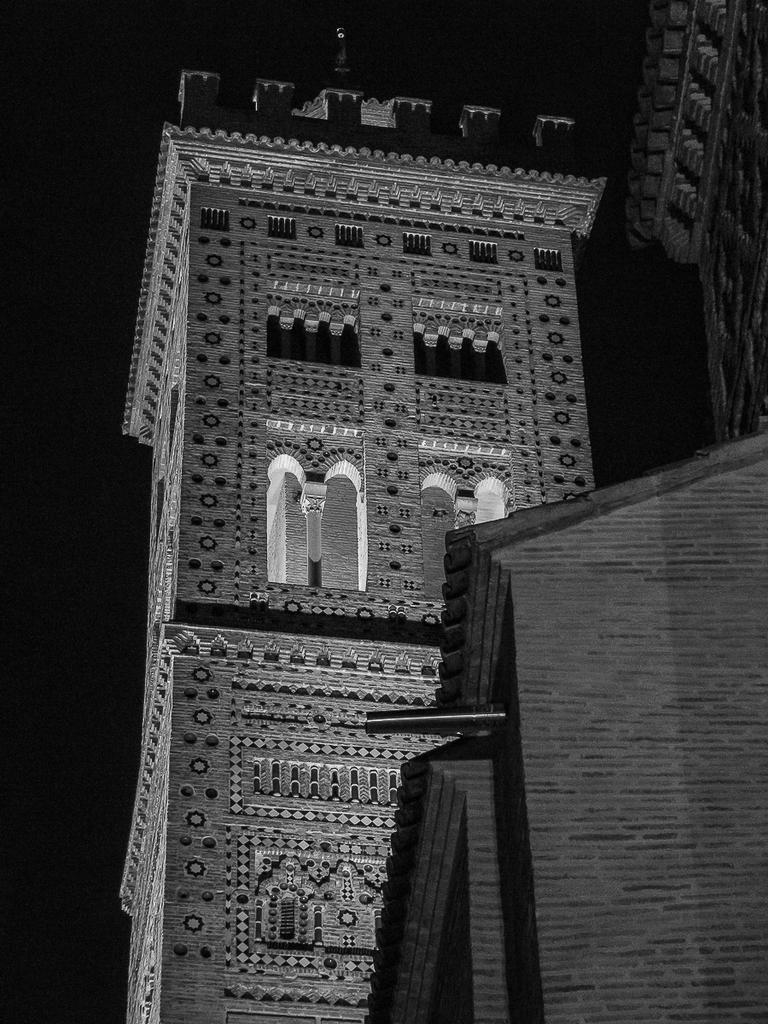Can you describe this image briefly? In this picture we can observe a building. The background is completely dark. This is a black and white image. 